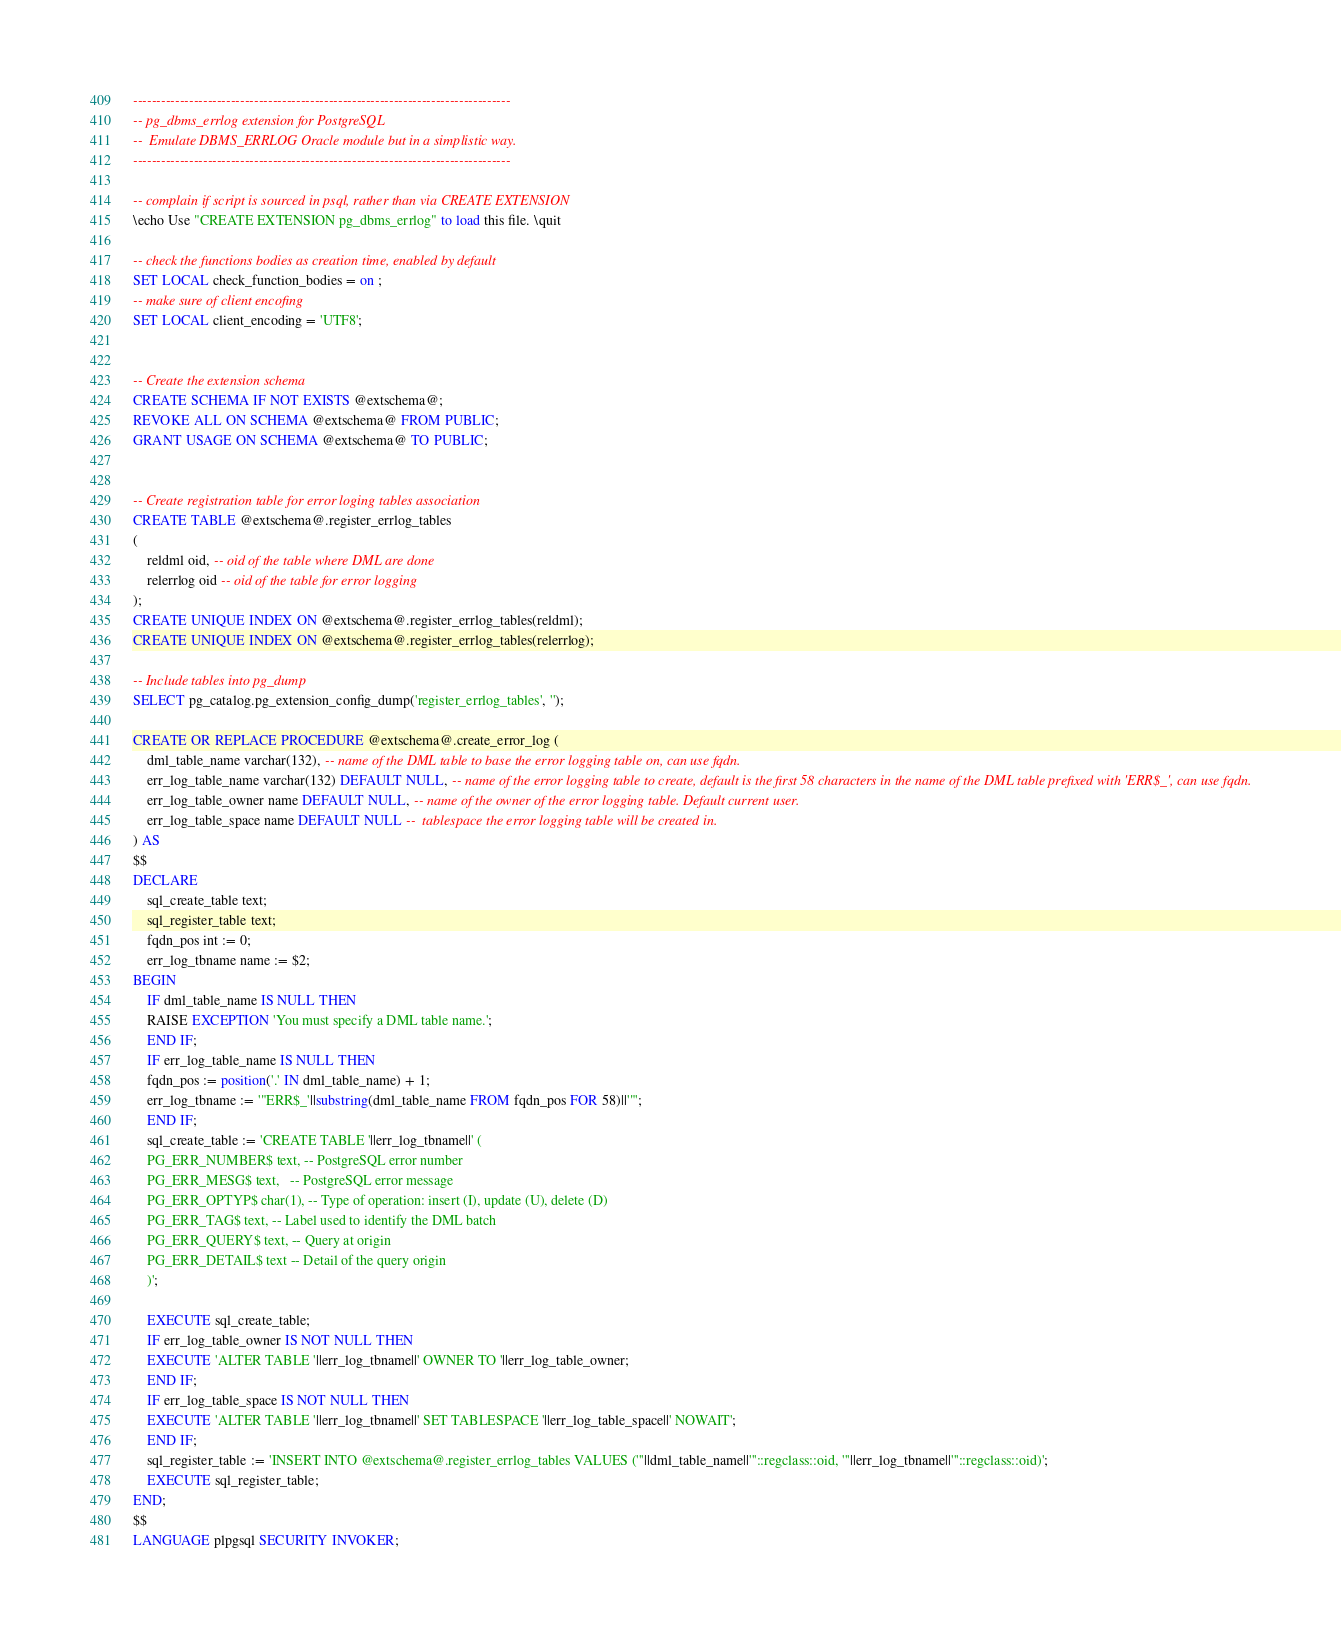<code> <loc_0><loc_0><loc_500><loc_500><_SQL_>---------------------------------------------------------------------------------
-- pg_dbms_errlog extension for PostgreSQL
--	Emulate DBMS_ERRLOG Oracle module but in a simplistic way.
---------------------------------------------------------------------------------

-- complain if script is sourced in psql, rather than via CREATE EXTENSION
\echo Use "CREATE EXTENSION pg_dbms_errlog" to load this file. \quit

-- check the functions bodies as creation time, enabled by default
SET LOCAL check_function_bodies = on ;
-- make sure of client encofing
SET LOCAL client_encoding = 'UTF8';


-- Create the extension schema
CREATE SCHEMA IF NOT EXISTS @extschema@;
REVOKE ALL ON SCHEMA @extschema@ FROM PUBLIC;
GRANT USAGE ON SCHEMA @extschema@ TO PUBLIC;


-- Create registration table for error loging tables association
CREATE TABLE @extschema@.register_errlog_tables
(
	reldml oid, -- oid of the table where DML are done
	relerrlog oid -- oid of the table for error logging
);
CREATE UNIQUE INDEX ON @extschema@.register_errlog_tables(reldml);
CREATE UNIQUE INDEX ON @extschema@.register_errlog_tables(relerrlog);

-- Include tables into pg_dump
SELECT pg_catalog.pg_extension_config_dump('register_errlog_tables', '');

CREATE OR REPLACE PROCEDURE @extschema@.create_error_log (
    dml_table_name varchar(132), -- name of the DML table to base the error logging table on, can use fqdn.
    err_log_table_name varchar(132) DEFAULT NULL, -- name of the error logging table to create, default is the first 58 characters in the name of the DML table prefixed with 'ERR$_', can use fqdn.
    err_log_table_owner name DEFAULT NULL, -- name of the owner of the error logging table. Default current user.
    err_log_table_space name DEFAULT NULL --  tablespace the error logging table will be created in.
) AS
$$
DECLARE
    sql_create_table text;
    sql_register_table text;
    fqdn_pos int := 0;
    err_log_tbname name := $2;
BEGIN
    IF dml_table_name IS NULL THEN
	RAISE EXCEPTION 'You must specify a DML table name.';
    END IF;
    IF err_log_table_name IS NULL THEN
	fqdn_pos := position('.' IN dml_table_name) + 1;
	err_log_tbname := '"ERR$_'||substring(dml_table_name FROM fqdn_pos FOR 58)||'"';
    END IF;
    sql_create_table := 'CREATE TABLE '||err_log_tbname||' (
	PG_ERR_NUMBER$ text, -- PostgreSQL error number
	PG_ERR_MESG$ text,   -- PostgreSQL error message
	PG_ERR_OPTYP$ char(1), -- Type of operation: insert (I), update (U), delete (D)
	PG_ERR_TAG$ text, -- Label used to identify the DML batch
	PG_ERR_QUERY$ text, -- Query at origin
	PG_ERR_DETAIL$ text -- Detail of the query origin
	)';

    EXECUTE sql_create_table;
    IF err_log_table_owner IS NOT NULL THEN
	EXECUTE 'ALTER TABLE '||err_log_tbname||' OWNER TO '||err_log_table_owner;
    END IF;
    IF err_log_table_space IS NOT NULL THEN
	EXECUTE 'ALTER TABLE '||err_log_tbname||' SET TABLESPACE '||err_log_table_space||' NOWAIT';
    END IF;
    sql_register_table := 'INSERT INTO @extschema@.register_errlog_tables VALUES ('''||dml_table_name||'''::regclass::oid, '''||err_log_tbname||'''::regclass::oid)';
    EXECUTE sql_register_table;
END;
$$
LANGUAGE plpgsql SECURITY INVOKER;

</code> 